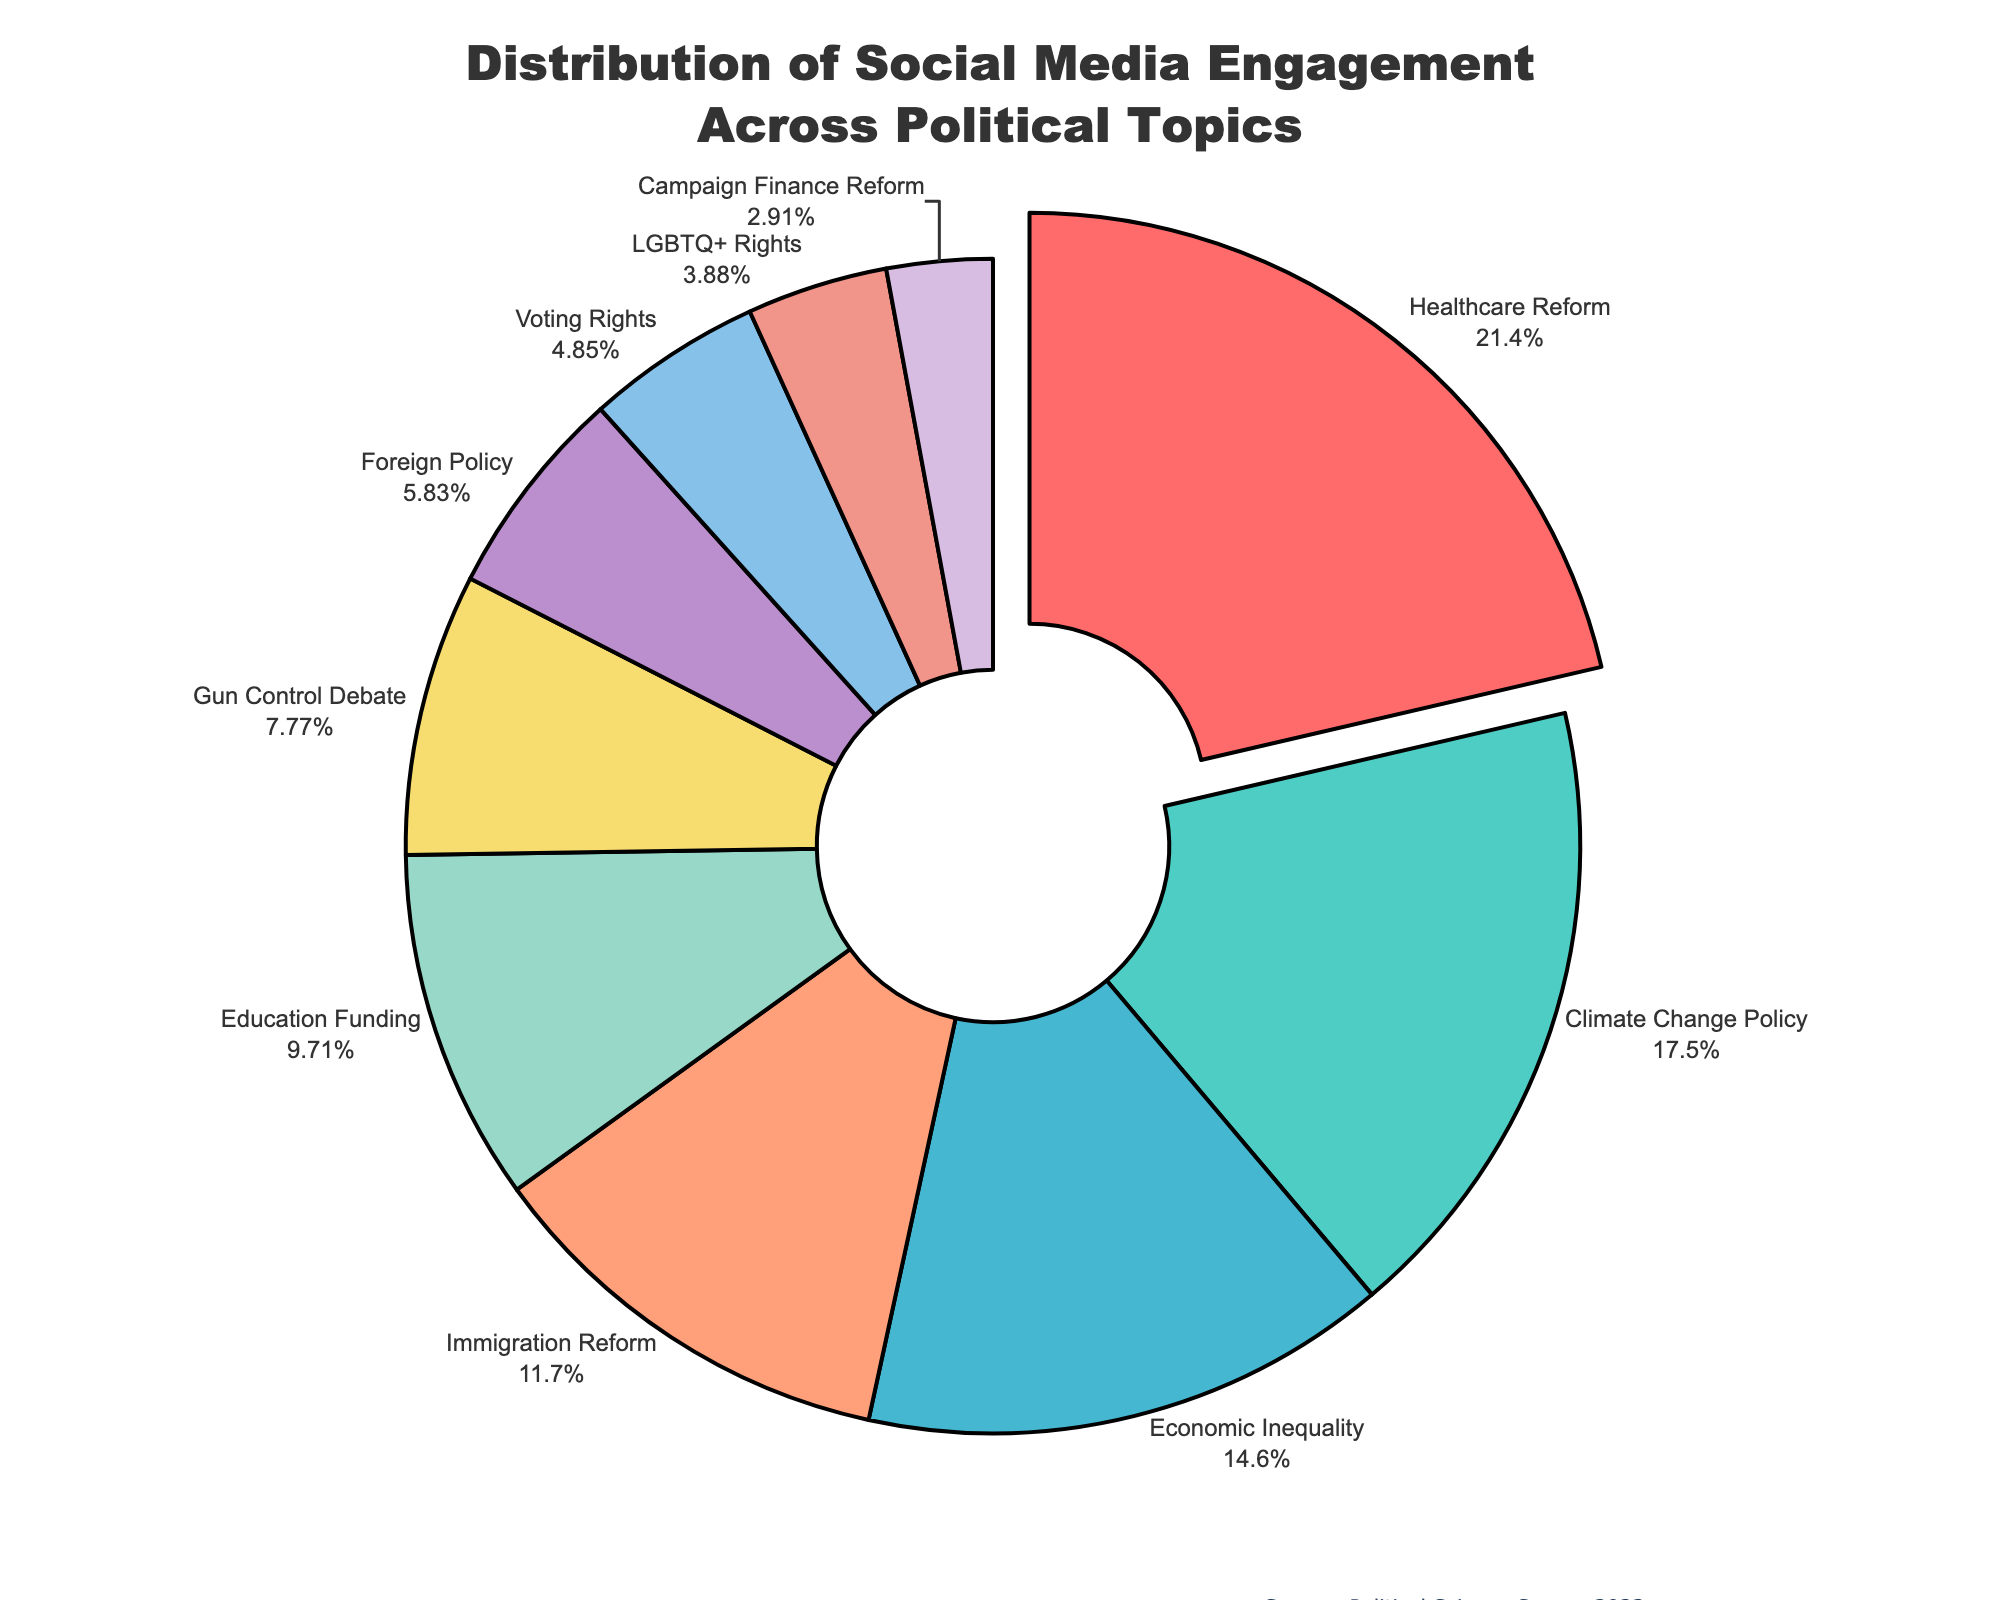What's the most engaging political topic on social media? The topic with the highest engagement percentage is highlighted outward and is labeled "Healthcare Reform" with an engagement of 22%.
Answer: Healthcare Reform Which political topic has the lowest engagement percentage and what is it? The segment with the lowest percentage is labeled "Campaign Finance Reform" and shows 3% engagement.
Answer: Campaign Finance Reform By how much does the engagement percentage for Healthcare Reform exceed that of Climate Change Policy? The engagement percentage for Healthcare Reform is 22% and for Climate Change Policy is 18%. The difference is calculated by subtracting 18 from 22.
Answer: 4% Which topics have a combined engagement percentage of less than 10%? Both Voting Rights and LGBTQ+ Rights have individual engagement percentages of 5% and 4% respectively, combining to 9%.
Answer: Voting Rights and LGBTQ+ Rights If we combined the engagement percentages of Economic Inequality, Immigration Reform, and Education Funding, which single topic would their combined percentage surpass? The combined engagement percentages of Economic Inequality (15%), Immigration Reform (12%), and Education Funding (10%) is 37%. This surpasses the engagement of any single topic.
Answer: All single topics Is the engagement percentage for Economic Inequality greater than the combined engagement for Gun Control Debate and Foreign Policy? The engagement percentage of Economic Inequality is 15%, while the combined engagement of Gun Control Debate (8%) and Foreign Policy (6%) is 14%. So, 15% is greater than 14%.
Answer: Yes What is the color of the segment representing Climate Change Policy? The visual attribute of Climate Change Policy is depicted in green on the pie chart.
Answer: Green Which topic, after subtracting the engagement percentage of Voting Rights, still retains a double-digit engagement percentage? Subtracting the Voting Rights' engagement percentage (5%) from the engagement percentage of Economic Inequality (15%) yields 10%, which is still a double-digit figure.
Answer: Economic Inequality What's the average engagement percentage for the top three political topics? The engagement percentages for the top three topics (Healthcare Reform, Climate Change Policy, Economic Inequality) are 22%, 18%, and 15%. The sum is 55%, thus the average is 55/3.
Answer: 18.33% How many topics have an engagement percentage greater than or equal to 10%? By observing the pie chart, Healthcare Reform (22%), Climate Change Policy (18%), Economic Inequality (15%), Immigration Reform (12%), and Education Funding (10%) all meet the criteria.
Answer: 5 